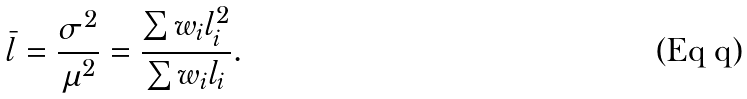Convert formula to latex. <formula><loc_0><loc_0><loc_500><loc_500>\bar { l } = \frac { \sigma ^ { 2 } } { \mu ^ { 2 } } = \frac { \sum w _ { i } l _ { i } ^ { 2 } } { \sum w _ { i } l _ { i } } .</formula> 